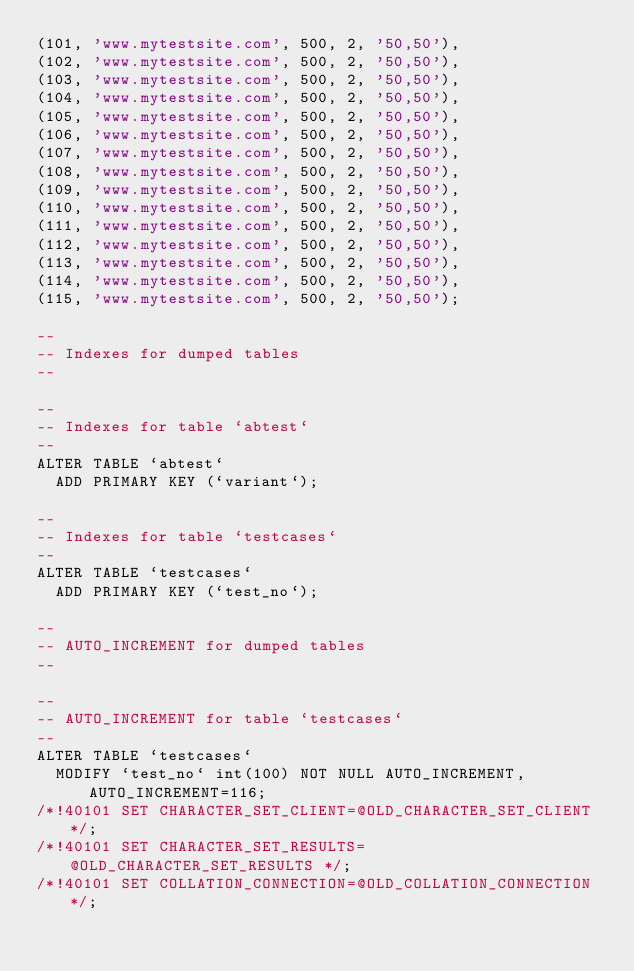<code> <loc_0><loc_0><loc_500><loc_500><_SQL_>(101, 'www.mytestsite.com', 500, 2, '50,50'),
(102, 'www.mytestsite.com', 500, 2, '50,50'),
(103, 'www.mytestsite.com', 500, 2, '50,50'),
(104, 'www.mytestsite.com', 500, 2, '50,50'),
(105, 'www.mytestsite.com', 500, 2, '50,50'),
(106, 'www.mytestsite.com', 500, 2, '50,50'),
(107, 'www.mytestsite.com', 500, 2, '50,50'),
(108, 'www.mytestsite.com', 500, 2, '50,50'),
(109, 'www.mytestsite.com', 500, 2, '50,50'),
(110, 'www.mytestsite.com', 500, 2, '50,50'),
(111, 'www.mytestsite.com', 500, 2, '50,50'),
(112, 'www.mytestsite.com', 500, 2, '50,50'),
(113, 'www.mytestsite.com', 500, 2, '50,50'),
(114, 'www.mytestsite.com', 500, 2, '50,50'),
(115, 'www.mytestsite.com', 500, 2, '50,50');

--
-- Indexes for dumped tables
--

--
-- Indexes for table `abtest`
--
ALTER TABLE `abtest`
  ADD PRIMARY KEY (`variant`);

--
-- Indexes for table `testcases`
--
ALTER TABLE `testcases`
  ADD PRIMARY KEY (`test_no`);

--
-- AUTO_INCREMENT for dumped tables
--

--
-- AUTO_INCREMENT for table `testcases`
--
ALTER TABLE `testcases`
  MODIFY `test_no` int(100) NOT NULL AUTO_INCREMENT, AUTO_INCREMENT=116;
/*!40101 SET CHARACTER_SET_CLIENT=@OLD_CHARACTER_SET_CLIENT */;
/*!40101 SET CHARACTER_SET_RESULTS=@OLD_CHARACTER_SET_RESULTS */;
/*!40101 SET COLLATION_CONNECTION=@OLD_COLLATION_CONNECTION */;
</code> 